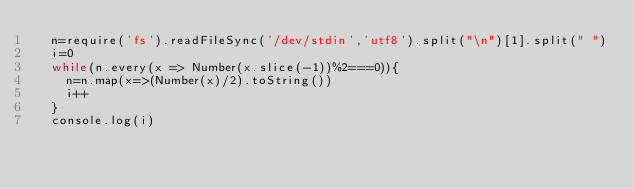<code> <loc_0><loc_0><loc_500><loc_500><_JavaScript_>  n=require('fs').readFileSync('/dev/stdin','utf8').split("\n")[1].split(" ")
  i=0
  while(n.every(x => Number(x.slice(-1))%2===0)){
    n=n.map(x=>(Number(x)/2).toString())
    i++
  }
  console.log(i)</code> 